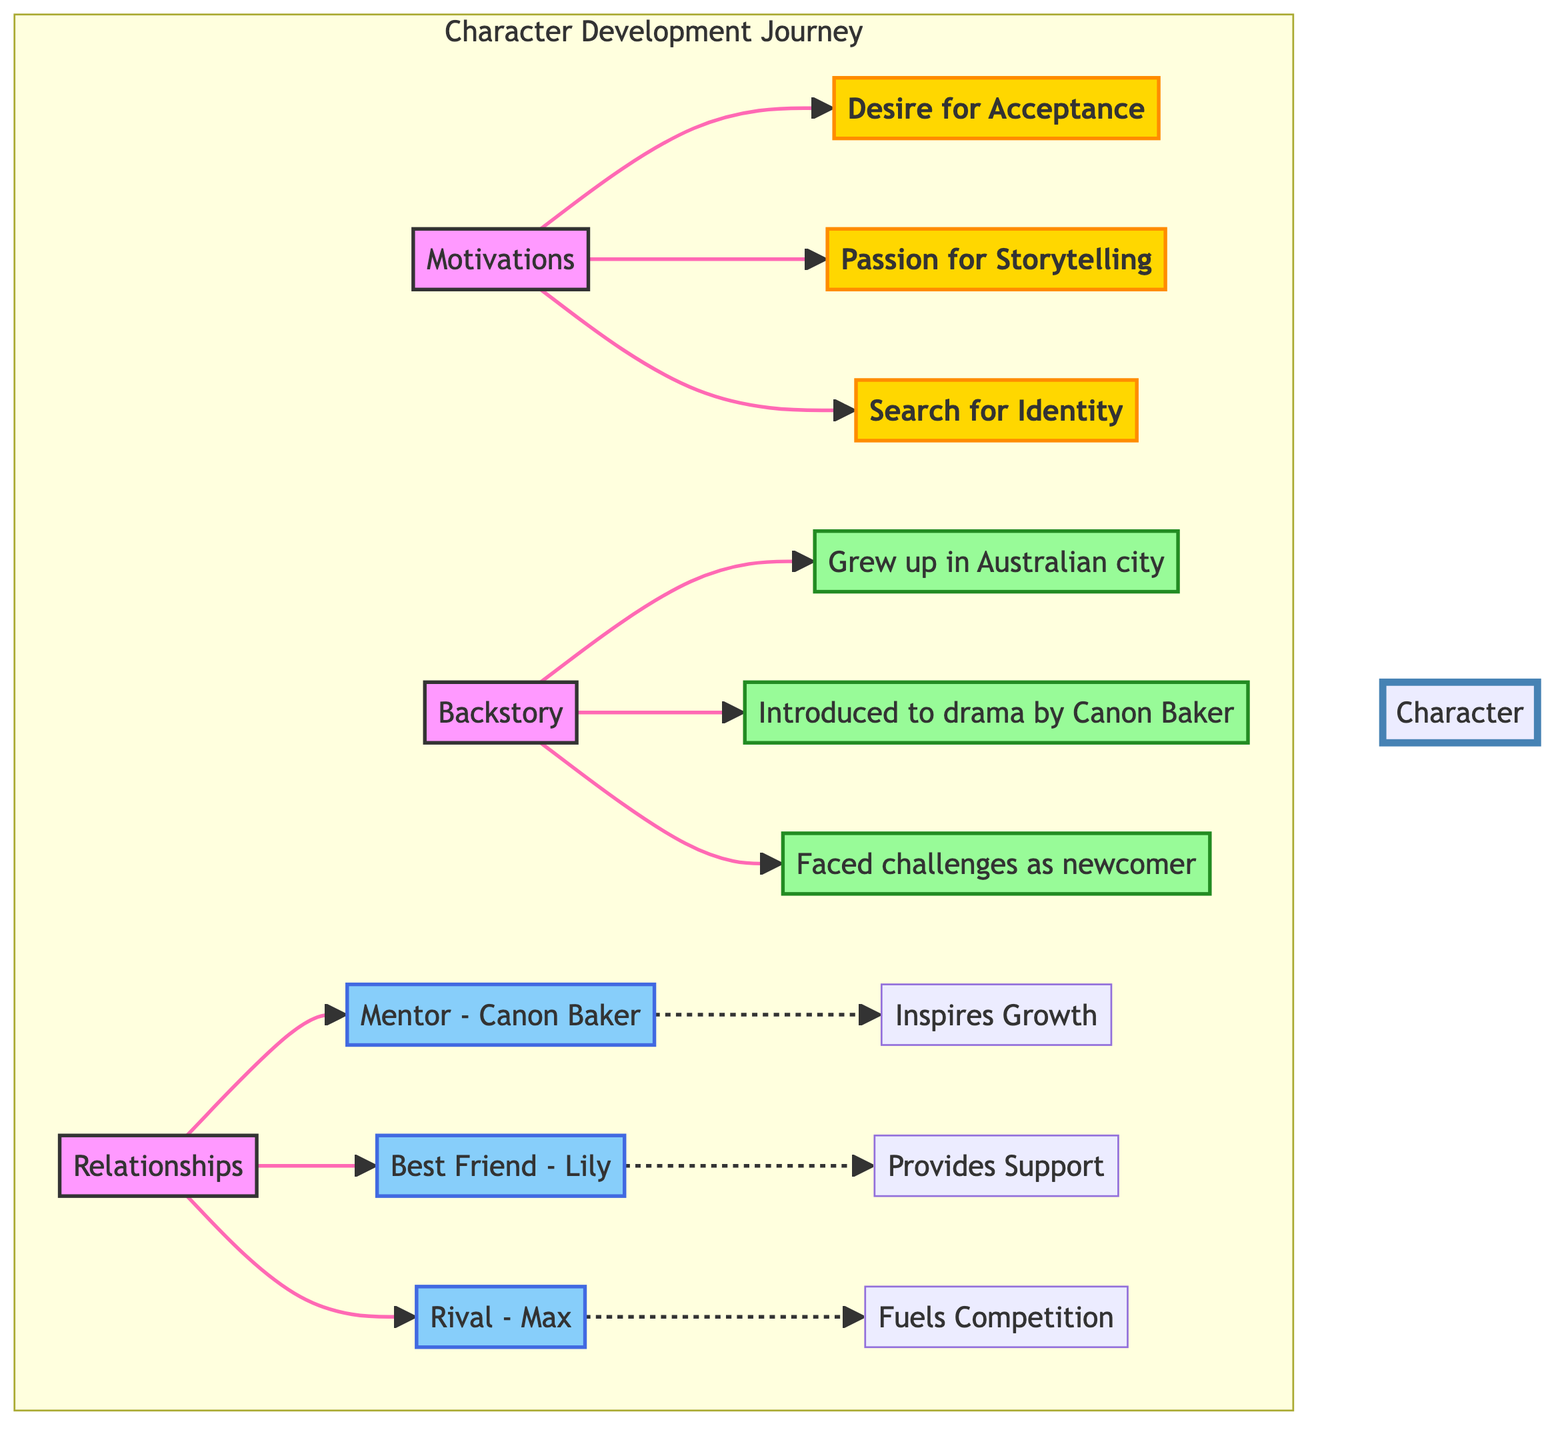What are the three main motivations in the character development journey? The diagram lists the motivations under a specific node labeled "Motivations." Upon checking the connections from the "Motivations" node, we can see three items listed: "Desire for Acceptance in Theatre Community," "Passion for Storytelling and Expression," and "Search for Identity and Self-Discovery."
Answer: Desire for Acceptance in Theatre Community, Passion for Storytelling and Expression, Search for Identity and Self-Discovery Who is the mentor character in the relationships section? Under the "Relationships" section, there is a connection to "Mentor - Canon Baker." This node indicates who the mentor character is, clearly labeled as "Canon Baker."
Answer: Canon Baker How many backstory elements are listed? The "Backstory" section has three connections leading to nodes labeled with backstory elements: "Grew up in a vibrant Australian city," "Introduced to drama by Canon Baker," and "Faced challenges as a newcomer to the acting scene." We count a total of three elements listed under backstory.
Answer: 3 What dynamic does the relationship with the best friend, Lily, provide? The diagram indicates a connection from "Best Friend - Lily" to "Provides Emotional Support and Guidance." By analyzing this connection, we can find that the dynamic provided is one of emotional support and guidance from Lily.
Answer: Provides Emotional Support and Guidance Which character challenges and fuels the competitive spirit? The diagram shows a relationship with a "Rival - Max," leading to "Challenges and Fuels Competitive Spirit." This implies that Max is the character who creates challenges and enhances competitiveness.
Answer: Max What motivates the character’s search for identity? The node labeled "Search for Identity and Self-Discovery" is one of the motivations listed in the "Motivations" section. This indicates that a desire related to identity is a specific motivation for the character.
Answer: Search for Identity and Self-Discovery How does Canon Baker influence the character’s growth? In the diagram, Canon Baker is connected to "Inspires Growth and Artistic Development." This indicates that Canon Baker plays a crucial role in fostering the character's growth artistically.
Answer: Inspires Growth and Artistic Development Which backstory element highlights the character's challenges in the acting scene? The connection "Faced challenges as a newcomer to the acting scene" under the "Backstory" node clearly addresses the character's struggles and provides insight into their challenges in the acting community.
Answer: Faced challenges as newcomer 